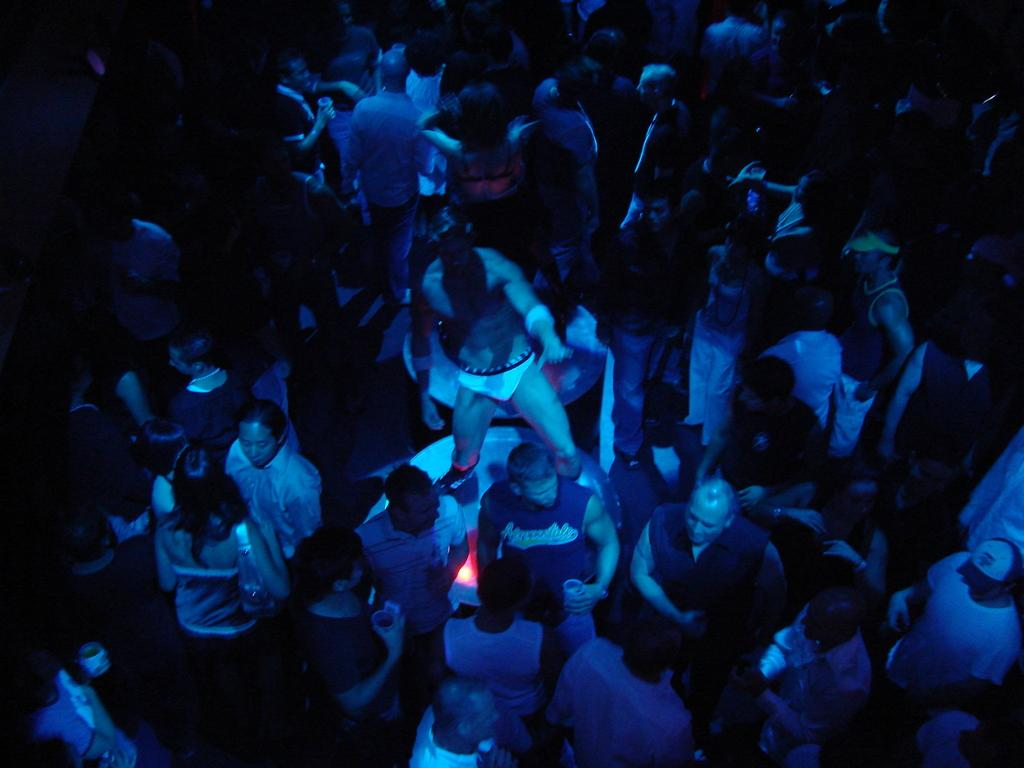Where was the image taken? The image was taken in a pub. How many people can be seen in the image? There are many people in the image. What can be observed about the lighting in the image? The edges of the image are dark. What type of brush can be seen hanging on the wall in the image? There is no brush visible in the image; it was taken in a pub, and no such object is mentioned in the provided facts. 